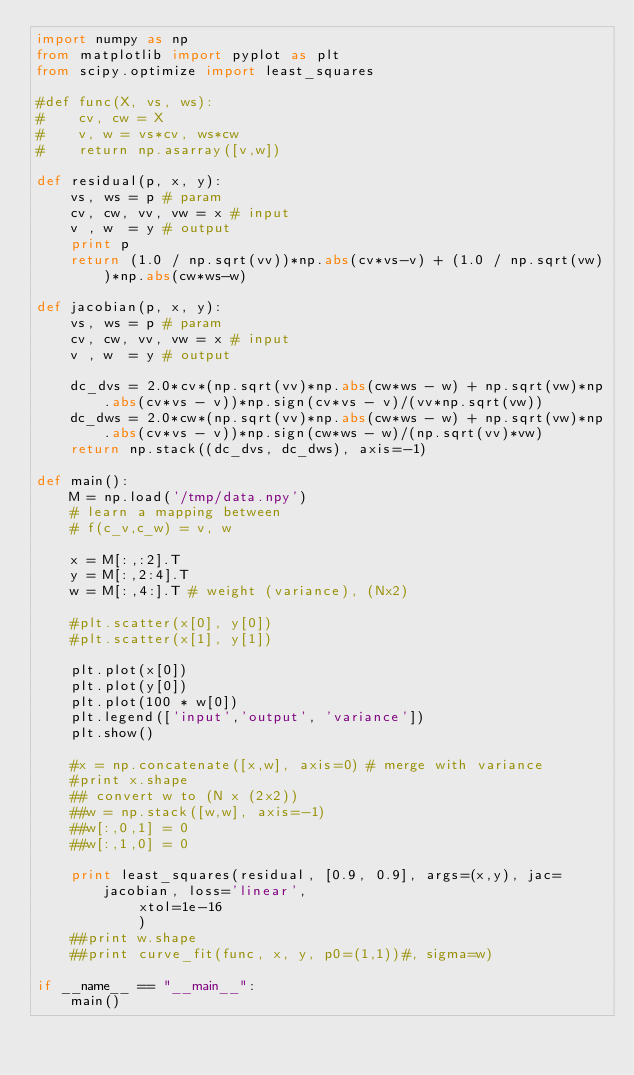<code> <loc_0><loc_0><loc_500><loc_500><_Python_>import numpy as np
from matplotlib import pyplot as plt
from scipy.optimize import least_squares

#def func(X, vs, ws):
#    cv, cw = X
#    v, w = vs*cv, ws*cw
#    return np.asarray([v,w])

def residual(p, x, y):
    vs, ws = p # param
    cv, cw, vv, vw = x # input
    v , w  = y # output
    print p
    return (1.0 / np.sqrt(vv))*np.abs(cv*vs-v) + (1.0 / np.sqrt(vw))*np.abs(cw*ws-w)

def jacobian(p, x, y):
    vs, ws = p # param
    cv, cw, vv, vw = x # input
    v , w  = y # output
    
    dc_dvs = 2.0*cv*(np.sqrt(vv)*np.abs(cw*ws - w) + np.sqrt(vw)*np.abs(cv*vs - v))*np.sign(cv*vs - v)/(vv*np.sqrt(vw))
    dc_dws = 2.0*cw*(np.sqrt(vv)*np.abs(cw*ws - w) + np.sqrt(vw)*np.abs(cv*vs - v))*np.sign(cw*ws - w)/(np.sqrt(vv)*vw)
    return np.stack((dc_dvs, dc_dws), axis=-1)

def main():
    M = np.load('/tmp/data.npy')
    # learn a mapping between
    # f(c_v,c_w) = v, w

    x = M[:,:2].T
    y = M[:,2:4].T
    w = M[:,4:].T # weight (variance), (Nx2)

    #plt.scatter(x[0], y[0])
    #plt.scatter(x[1], y[1])

    plt.plot(x[0])
    plt.plot(y[0])
    plt.plot(100 * w[0])
    plt.legend(['input','output', 'variance'])
    plt.show()

    #x = np.concatenate([x,w], axis=0) # merge with variance
    #print x.shape
    ## convert w to (N x (2x2))
    ##w = np.stack([w,w], axis=-1)
    ##w[:,0,1] = 0
    ##w[:,1,0] = 0

    print least_squares(residual, [0.9, 0.9], args=(x,y), jac=jacobian, loss='linear',
            xtol=1e-16
            )
    ##print w.shape
    ##print curve_fit(func, x, y, p0=(1,1))#, sigma=w)

if __name__ == "__main__":
    main()
</code> 